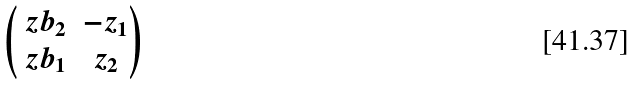Convert formula to latex. <formula><loc_0><loc_0><loc_500><loc_500>\begin{pmatrix} \ z b _ { 2 } & - z _ { 1 } \\ \ z b _ { 1 } & z _ { 2 } \end{pmatrix}</formula> 